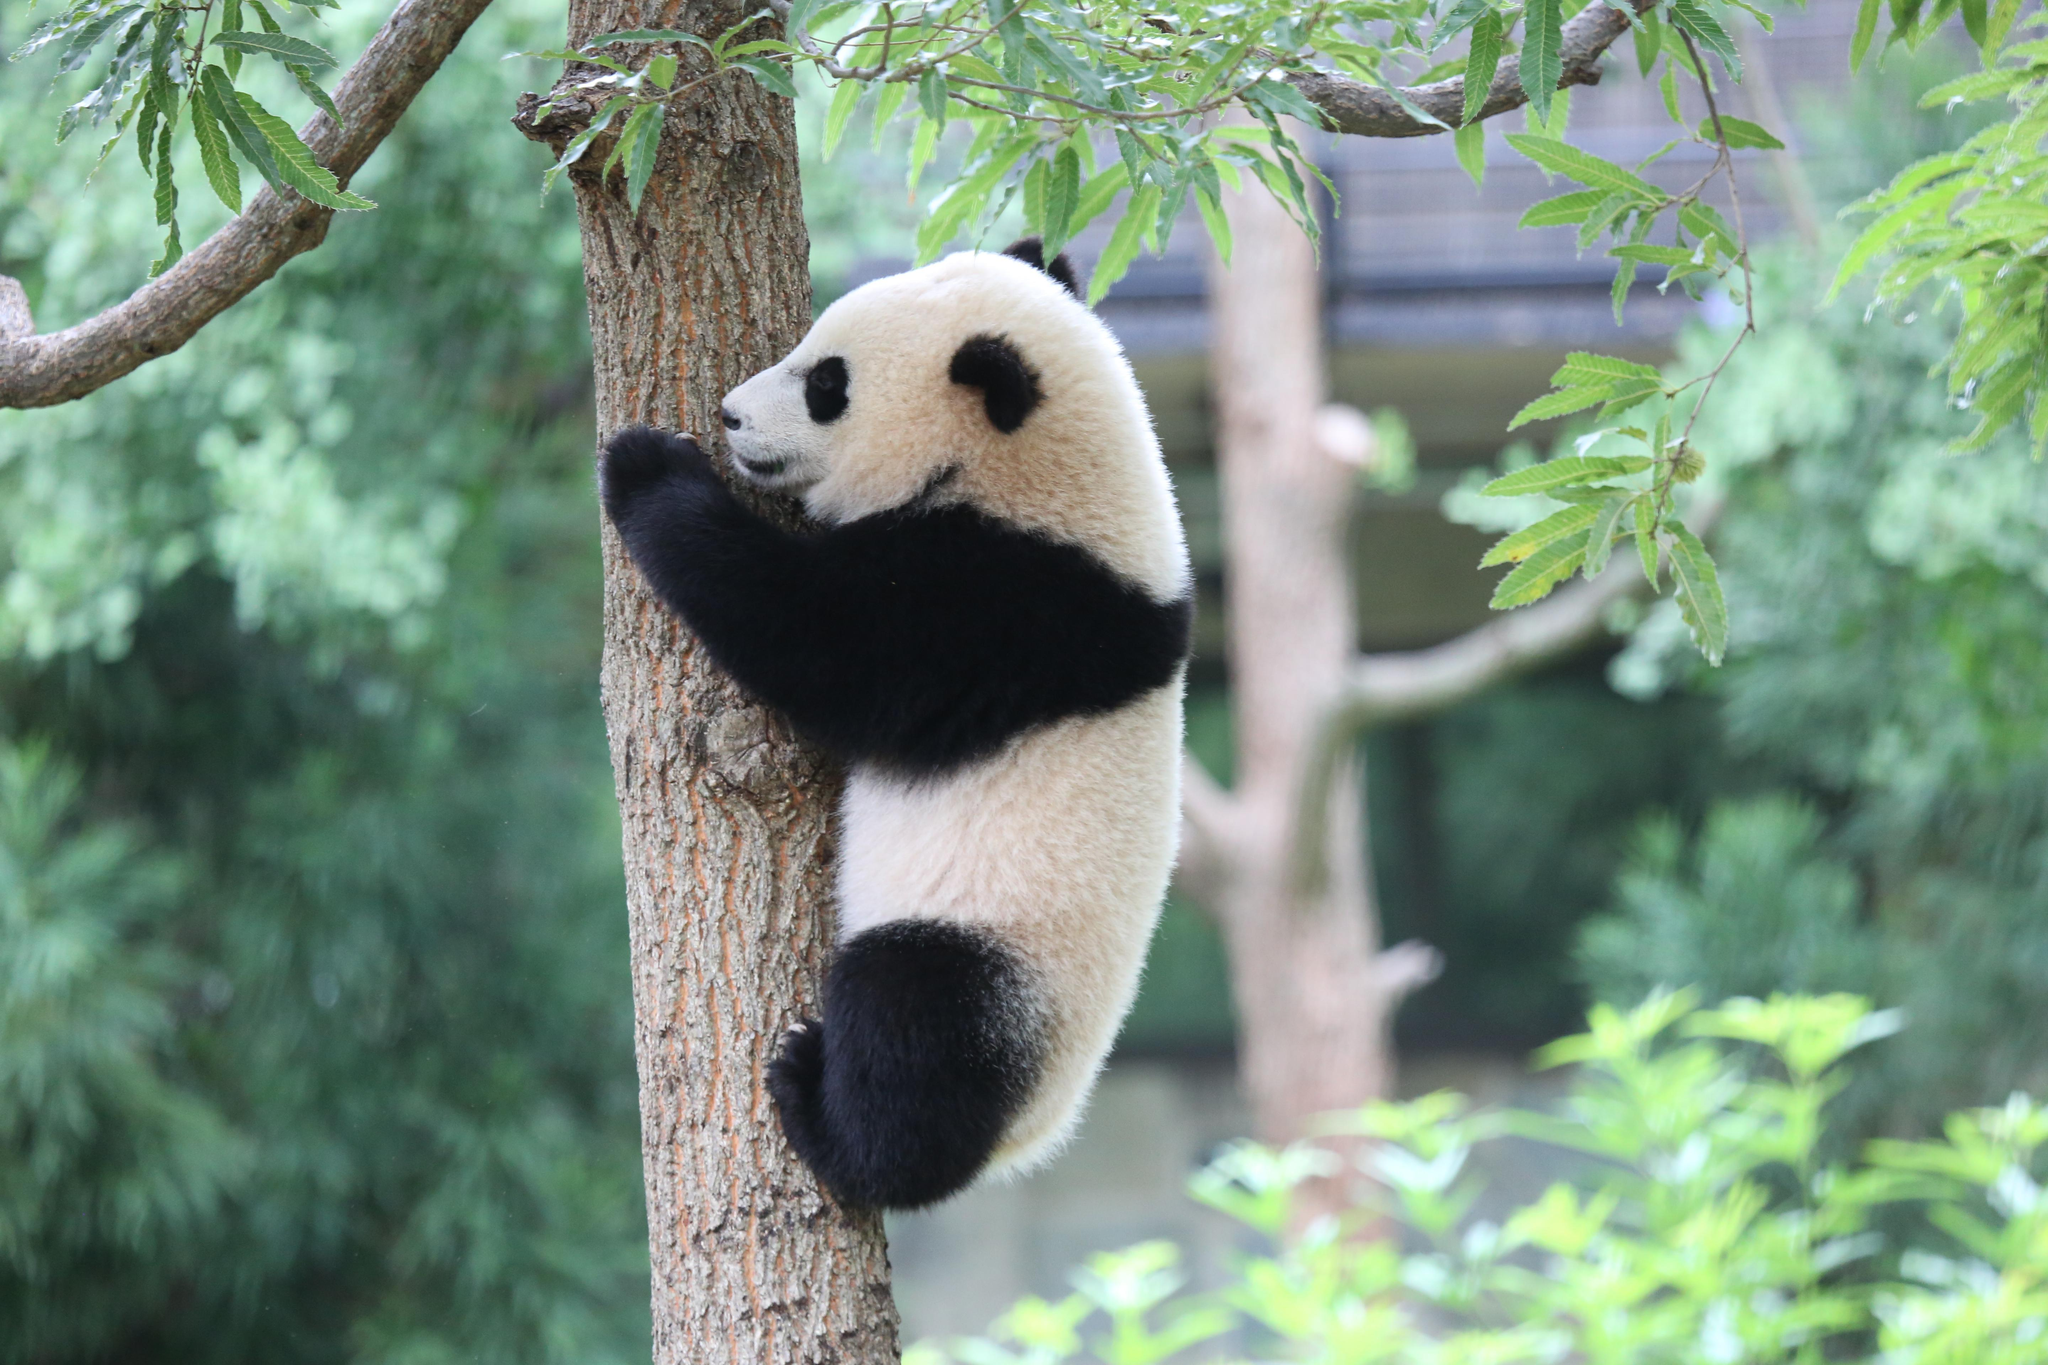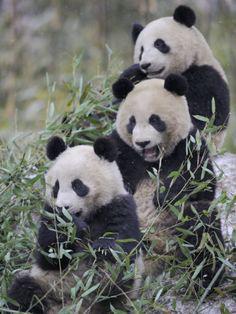The first image is the image on the left, the second image is the image on the right. Given the left and right images, does the statement "The panda in the image on the left is hanging against the side of a tree trunk." hold true? Answer yes or no. Yes. The first image is the image on the left, the second image is the image on the right. Considering the images on both sides, is "The right image shows one panda draped over part of a tree, with its hind legs hanging down." valid? Answer yes or no. No. 